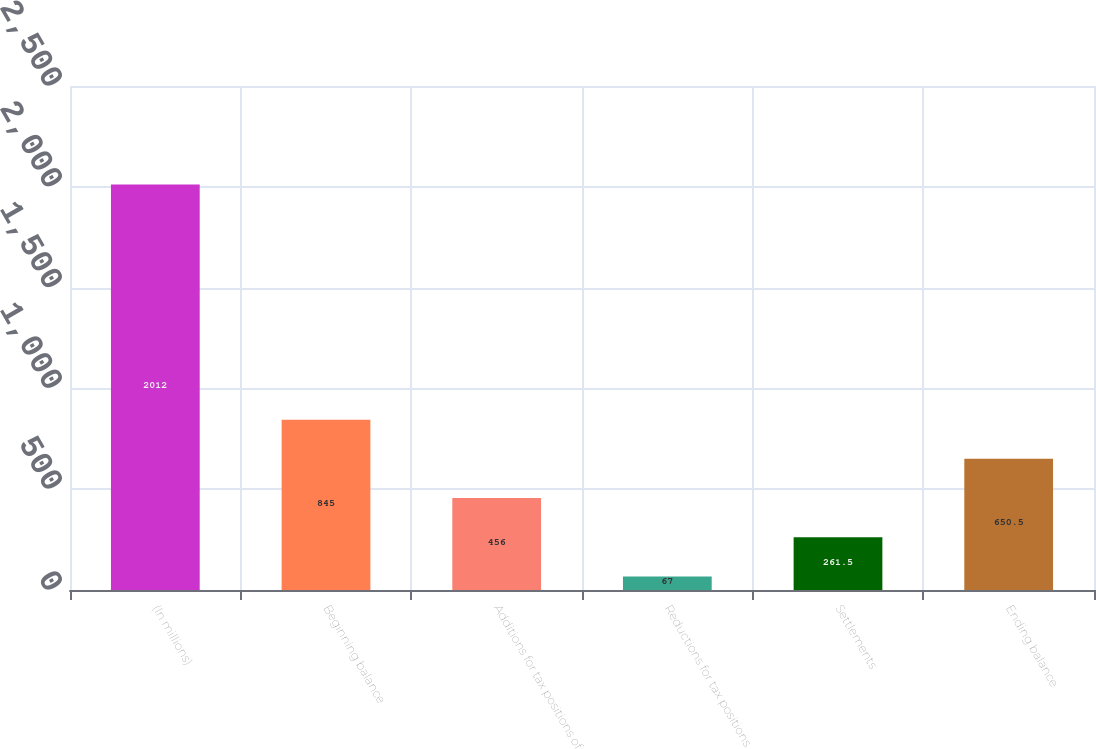<chart> <loc_0><loc_0><loc_500><loc_500><bar_chart><fcel>(In millions)<fcel>Beginning balance<fcel>Additions for tax positions of<fcel>Reductions for tax positions<fcel>Settlements<fcel>Ending balance<nl><fcel>2012<fcel>845<fcel>456<fcel>67<fcel>261.5<fcel>650.5<nl></chart> 